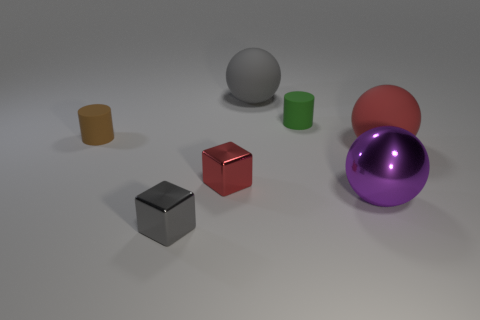Add 1 big red matte things. How many objects exist? 8 Subtract all cylinders. How many objects are left? 5 Add 1 large rubber spheres. How many large rubber spheres exist? 3 Subtract 0 cyan cubes. How many objects are left? 7 Subtract all green things. Subtract all cylinders. How many objects are left? 4 Add 1 big gray rubber things. How many big gray rubber things are left? 2 